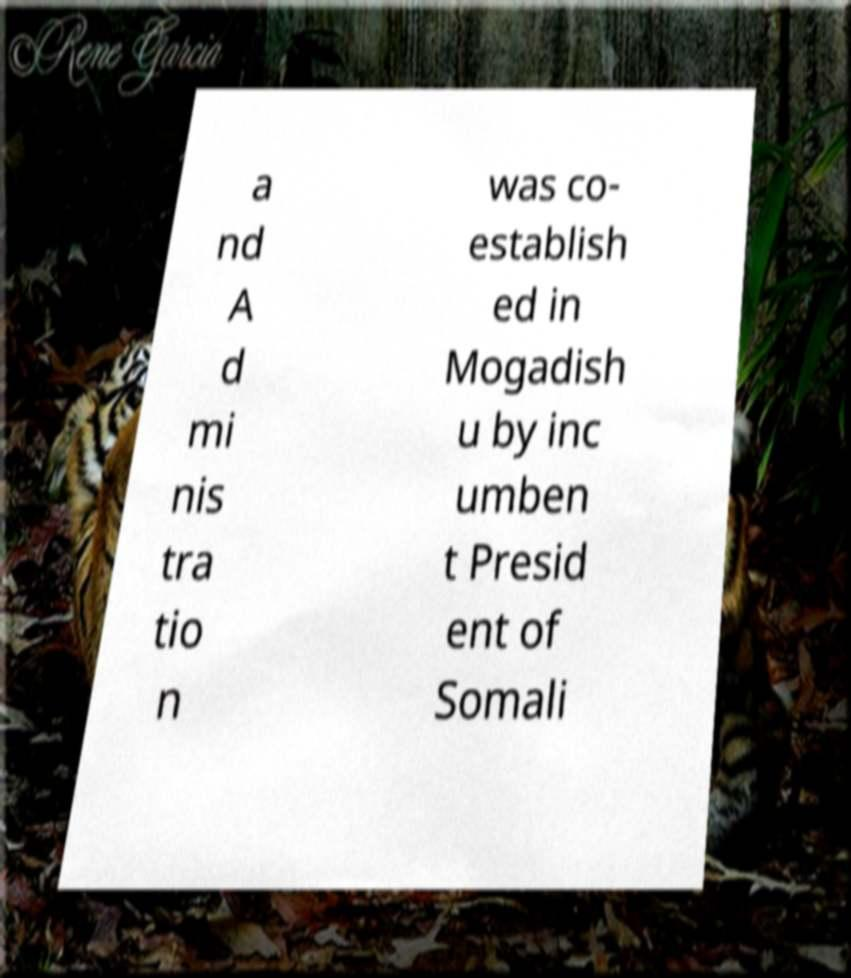I need the written content from this picture converted into text. Can you do that? a nd A d mi nis tra tio n was co- establish ed in Mogadish u by inc umben t Presid ent of Somali 